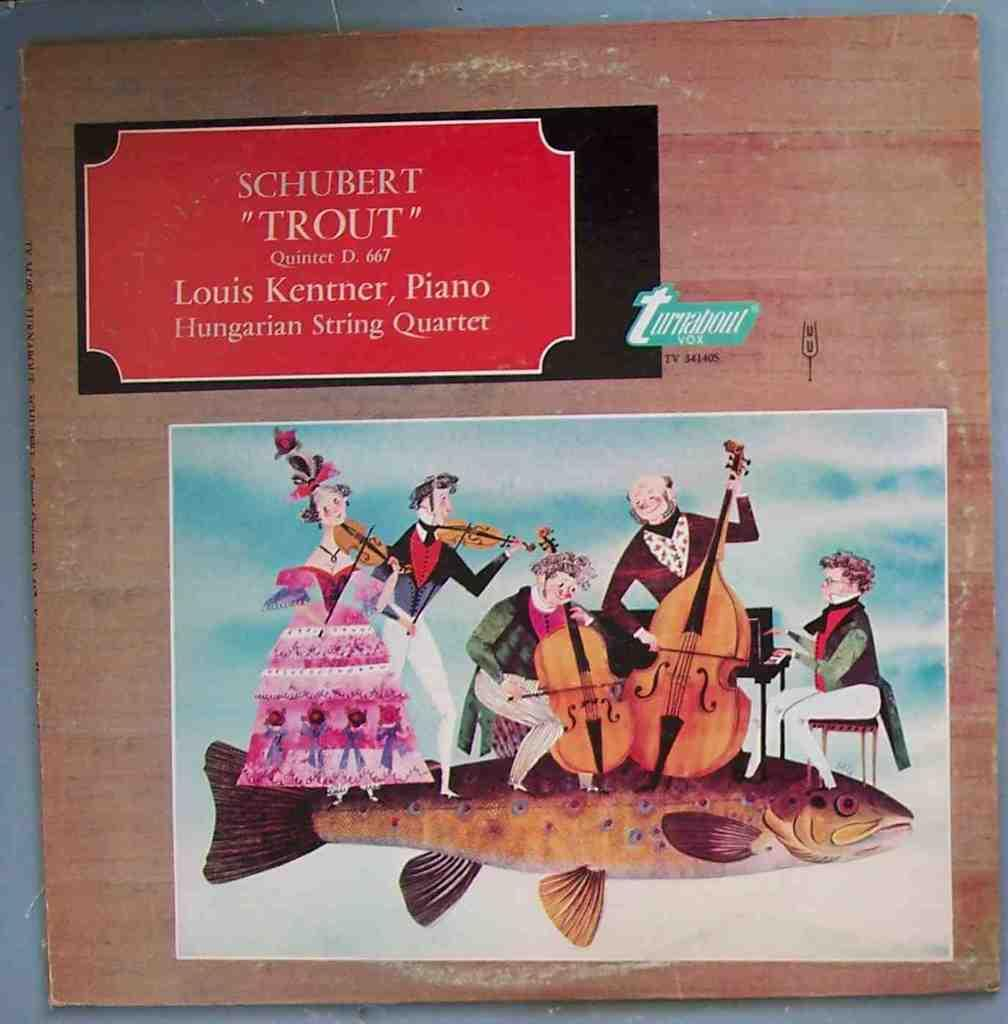<image>
Present a compact description of the photo's key features. Colorful cartoon image of the Hungarian String Quartet. 